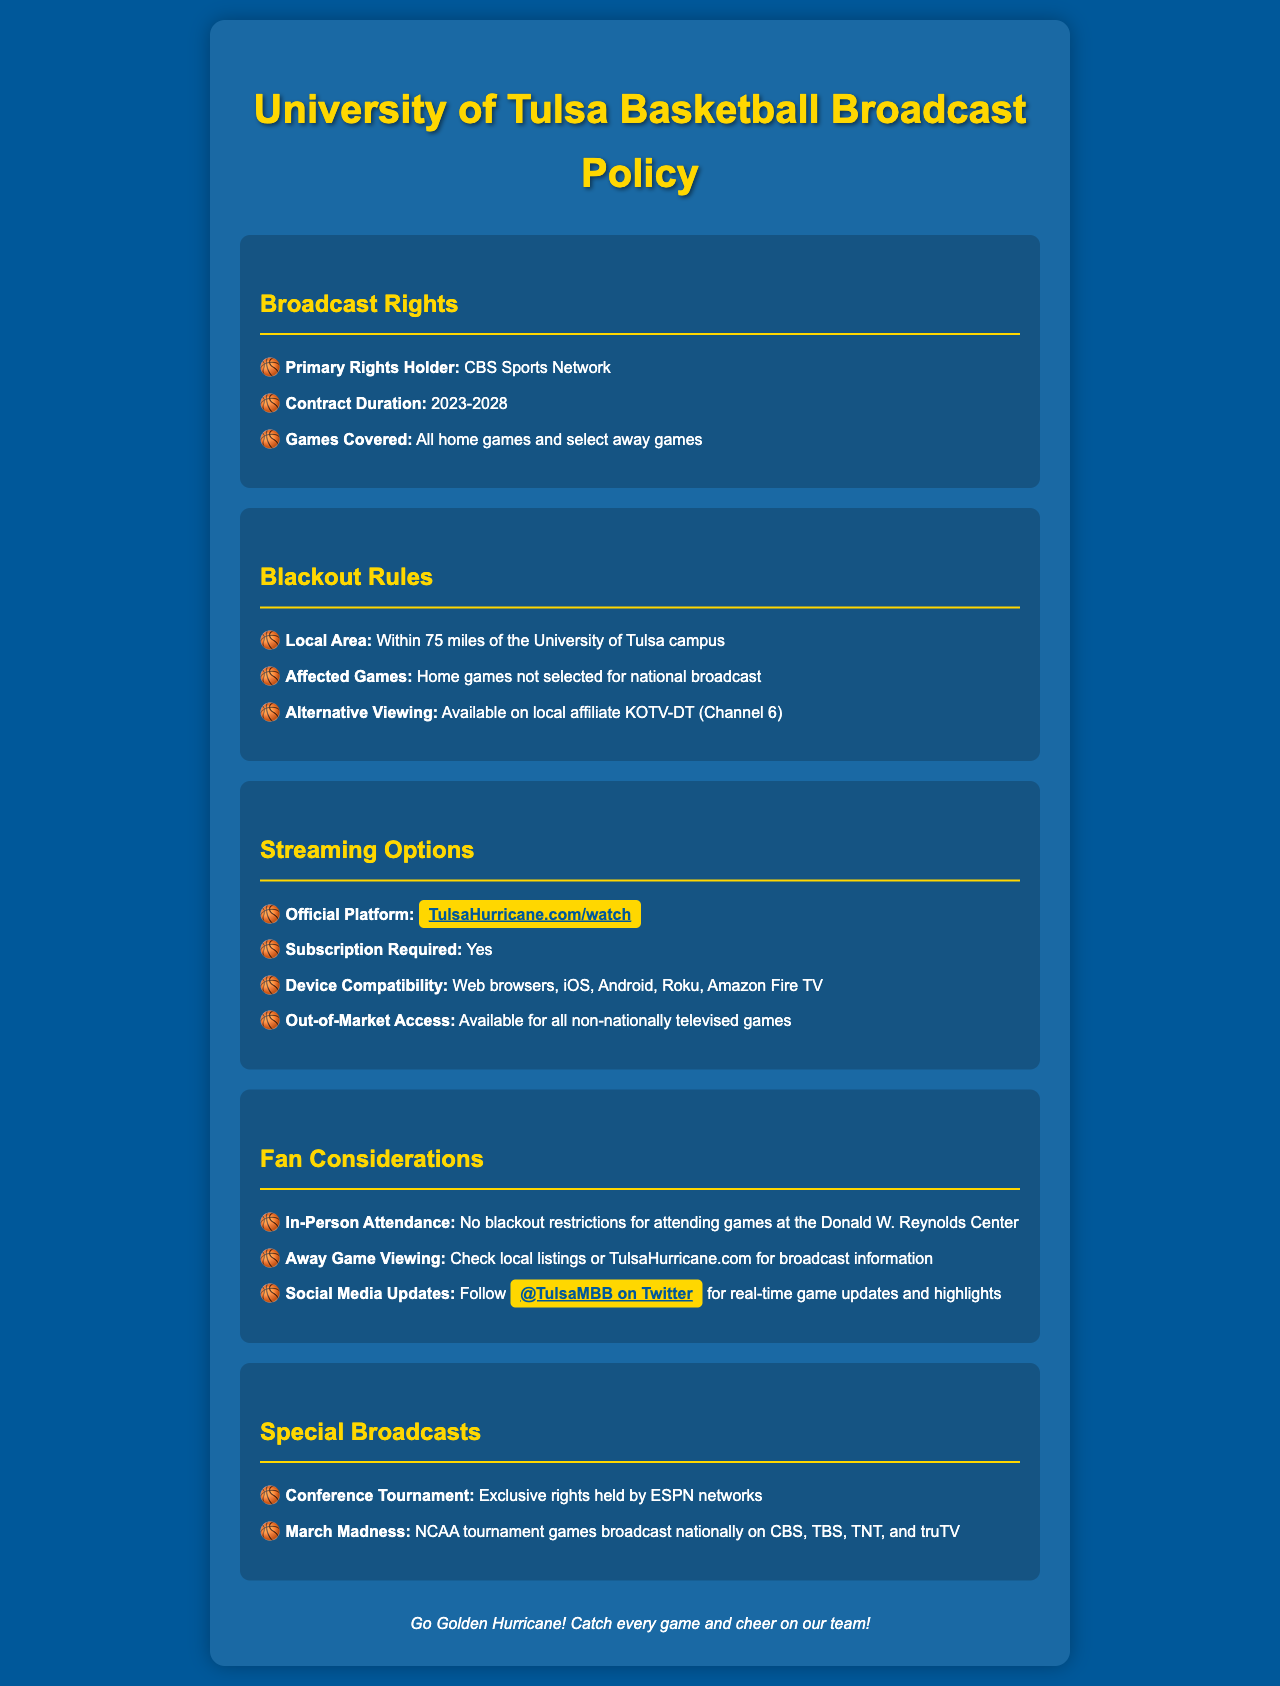What is the primary rights holder for broadcasts? The primary rights holder listed in the document is CBS Sports Network.
Answer: CBS Sports Network What is the contract duration for the broadcast rights? The contract duration is specified as 2023-2028.
Answer: 2023-2028 What are blackout rules for home games? Blackout rules apply to home games not selected for national broadcast within 75 miles of campus.
Answer: Within 75 miles of the University of Tulsa campus What platform is officially used for streaming? The official streaming platform mentioned in the document is TulsaHurricane.com/watch.
Answer: TulsaHurricane.com/watch Is a subscription required for streaming? The document states that a subscription is required for streaming.
Answer: Yes What devices are compatible with the streaming service? The document lists web browsers, iOS, Android, Roku, and Amazon Fire TV as compatible devices.
Answer: Web browsers, iOS, Android, Roku, Amazon Fire TV What should fans do for away game viewing? Fans are advised to check local listings or TulsaHurricane.com for away game broadcast information.
Answer: Check local listings or TulsaHurricane.com Where can real-time game updates be followed? Fans can follow real-time updates on Twitter at @TulsaMBB.
Answer: @TulsaMBB on Twitter Which networks hold rights to the Conference Tournament? The document states that exclusive rights to the Conference Tournament are held by ESPN networks.
Answer: ESPN networks 